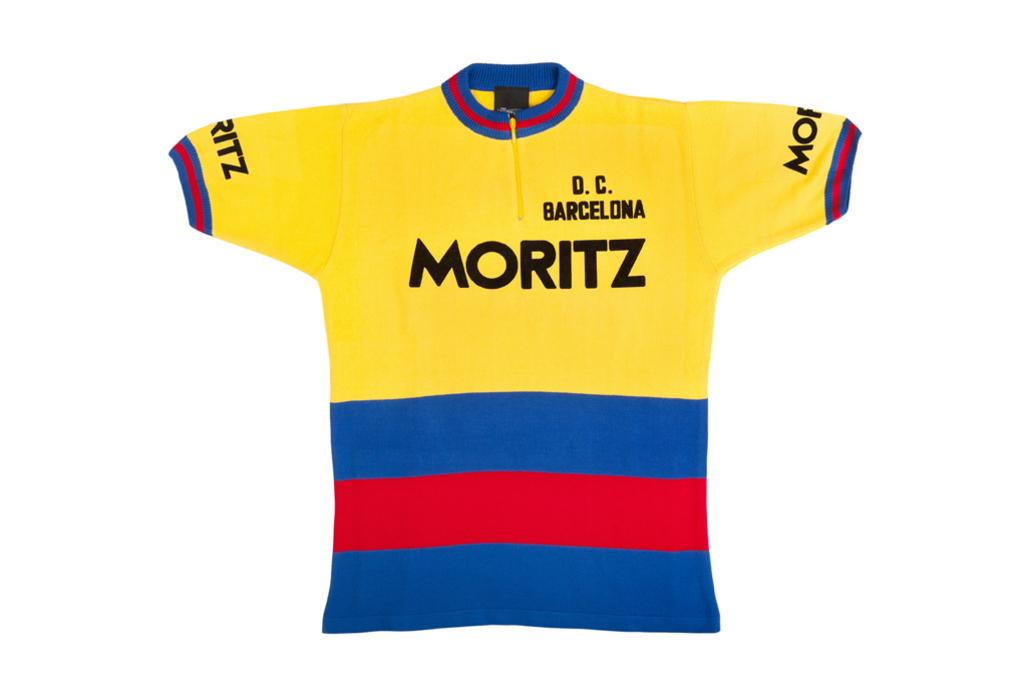<image>
Share a concise interpretation of the image provided. multi-color jersey for d.c. barcelona with name moritz on it 